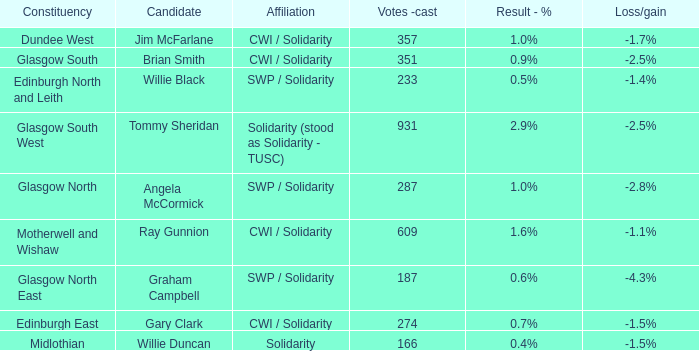What was the net gain or loss when 166 votes were cast? -1.5%. Parse the table in full. {'header': ['Constituency', 'Candidate', 'Affiliation', 'Votes -cast', 'Result - %', 'Loss/gain'], 'rows': [['Dundee West', 'Jim McFarlane', 'CWI / Solidarity', '357', '1.0%', '-1.7%'], ['Glasgow South', 'Brian Smith', 'CWI / Solidarity', '351', '0.9%', '-2.5%'], ['Edinburgh North and Leith', 'Willie Black', 'SWP / Solidarity', '233', '0.5%', '-1.4%'], ['Glasgow South West', 'Tommy Sheridan', 'Solidarity (stood as Solidarity - TUSC)', '931', '2.9%', '-2.5%'], ['Glasgow North', 'Angela McCormick', 'SWP / Solidarity', '287', '1.0%', '-2.8%'], ['Motherwell and Wishaw', 'Ray Gunnion', 'CWI / Solidarity', '609', '1.6%', '-1.1%'], ['Glasgow North East', 'Graham Campbell', 'SWP / Solidarity', '187', '0.6%', '-4.3%'], ['Edinburgh East', 'Gary Clark', 'CWI / Solidarity', '274', '0.7%', '-1.5%'], ['Midlothian', 'Willie Duncan', 'Solidarity', '166', '0.4%', '-1.5%']]} 